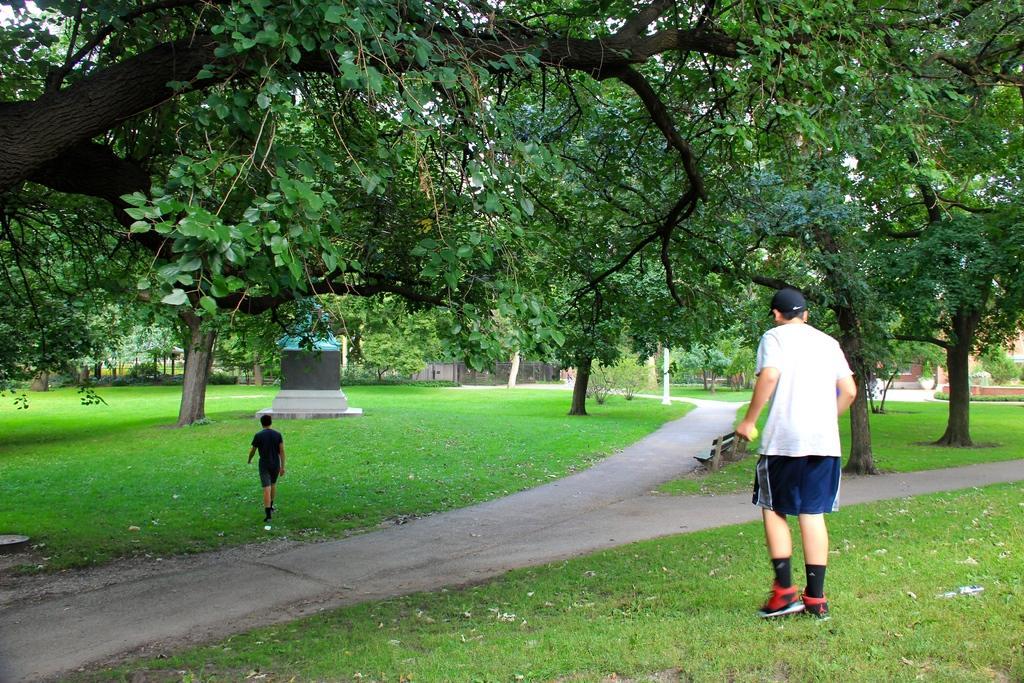How would you summarize this image in a sentence or two? In this image there is a man standing on the ground, on the right side. In front of him there is a road. In the middle of the image there is a statue. In front of the statue there is a boy who is walking on the ground. In the background there are trees. At the bottom there is grass. 